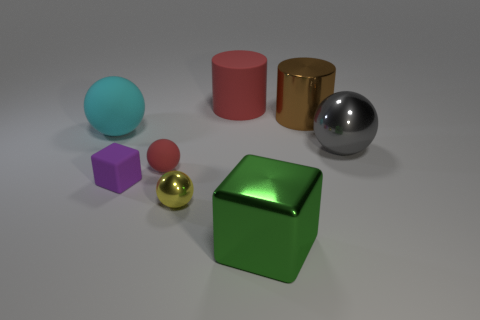How many other objects are there of the same size as the brown shiny cylinder?
Offer a terse response. 4. What is the size of the cylinder that is on the left side of the big object that is in front of the gray sphere?
Ensure brevity in your answer.  Large. How many small objects are brown metal objects or blue things?
Offer a very short reply. 0. How big is the cylinder right of the big cylinder left of the big shiny thing in front of the yellow metal ball?
Ensure brevity in your answer.  Large. Are there any other things that have the same color as the small metallic ball?
Make the answer very short. No. There is a yellow object that is behind the large shiny object that is in front of the cube to the left of the red ball; what is it made of?
Make the answer very short. Metal. Is the brown thing the same shape as the big red rubber thing?
Make the answer very short. Yes. What number of things are both to the right of the red sphere and in front of the tiny red sphere?
Make the answer very short. 2. The big ball behind the large sphere right of the large red cylinder is what color?
Ensure brevity in your answer.  Cyan. Are there the same number of cyan rubber objects right of the cyan rubber sphere and tiny blue rubber spheres?
Your answer should be compact. Yes. 